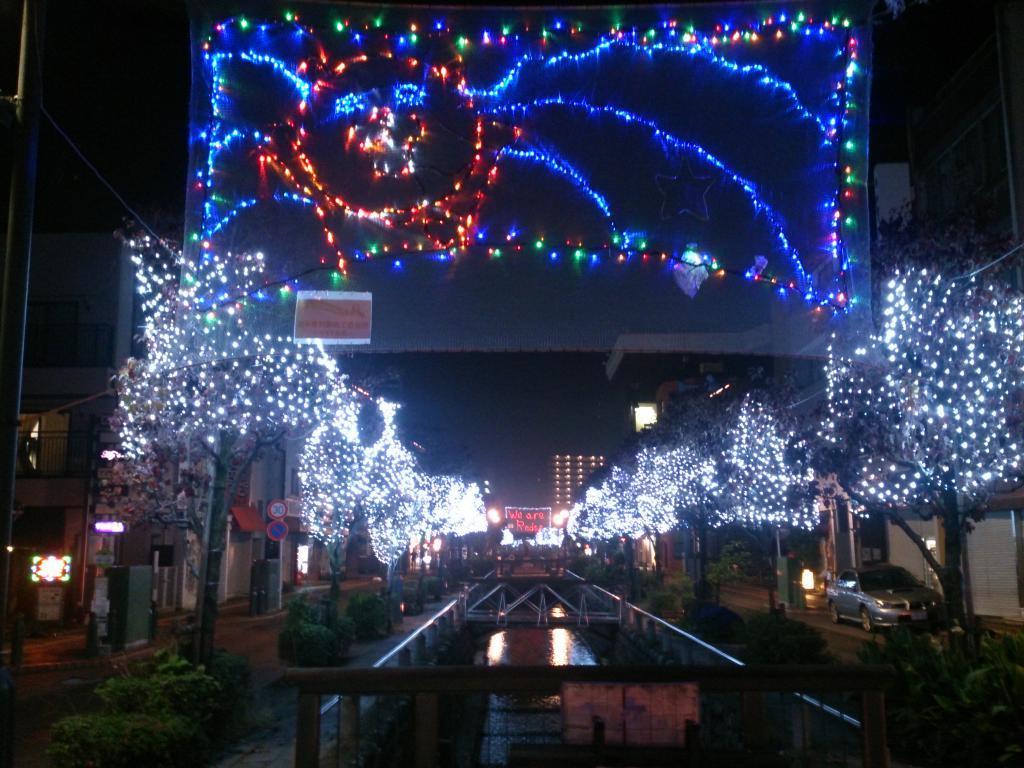How would you summarize this image in a sentence or two? In this image, we can see water and some objects. On the left and right side of the water, there are plants, trees and some decorative lights. On the right side of the image, there is a car. On the left side of the image, there are buildings and some other objects. At the top of the image, it looks like a banner with lights. Behind the buildings, there is the dark background. 